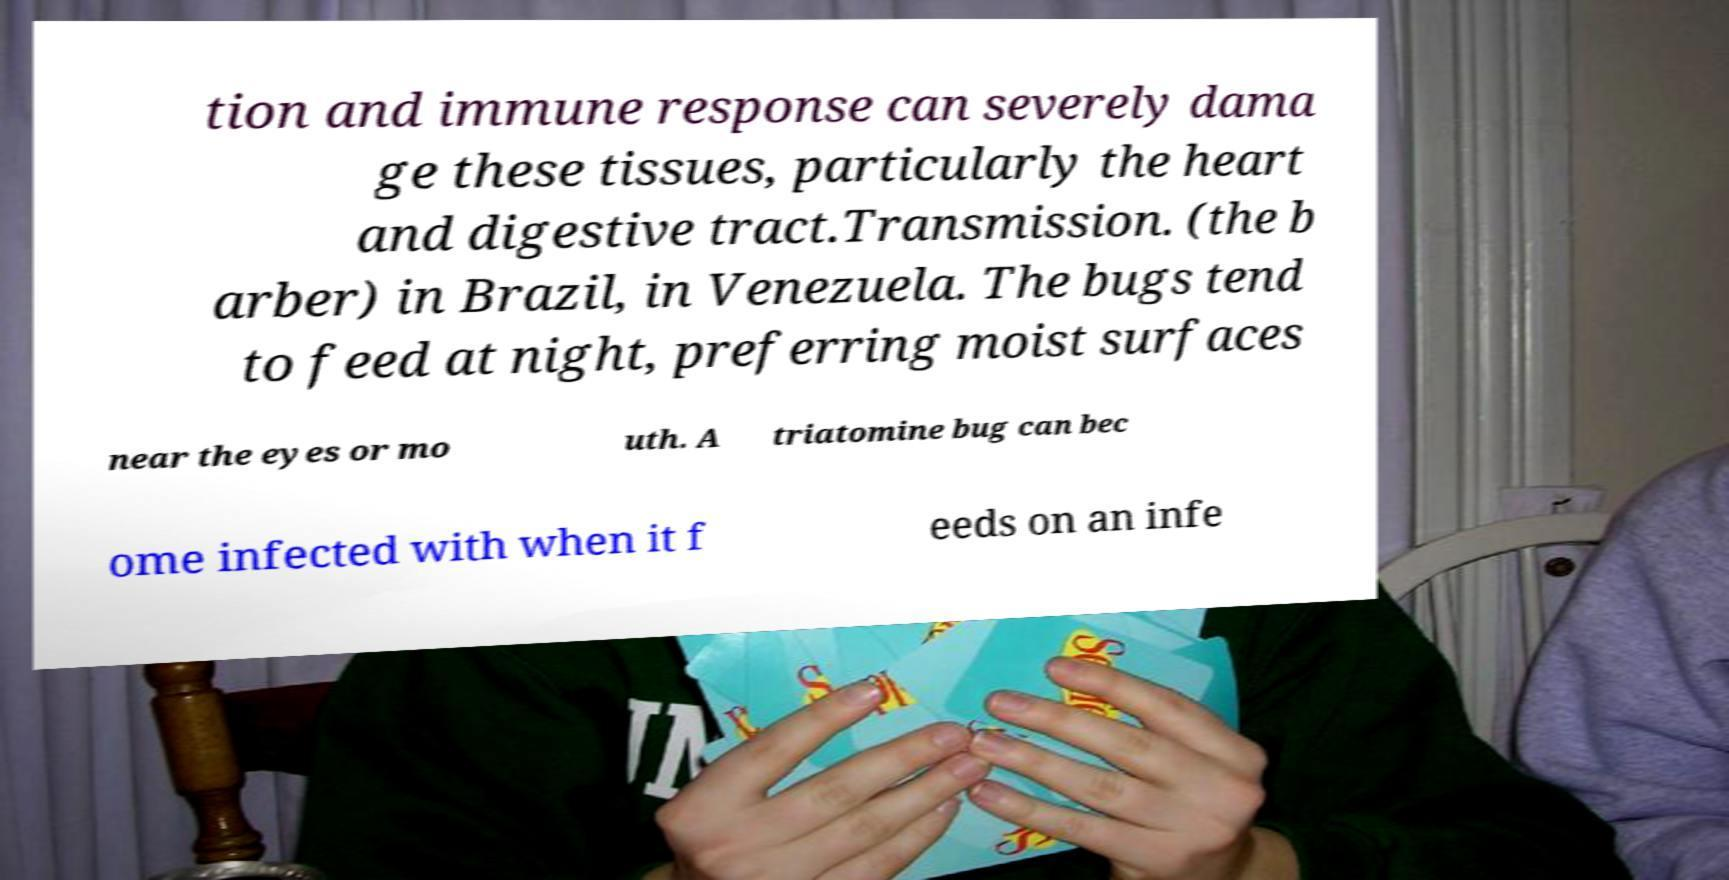Can you accurately transcribe the text from the provided image for me? tion and immune response can severely dama ge these tissues, particularly the heart and digestive tract.Transmission. (the b arber) in Brazil, in Venezuela. The bugs tend to feed at night, preferring moist surfaces near the eyes or mo uth. A triatomine bug can bec ome infected with when it f eeds on an infe 